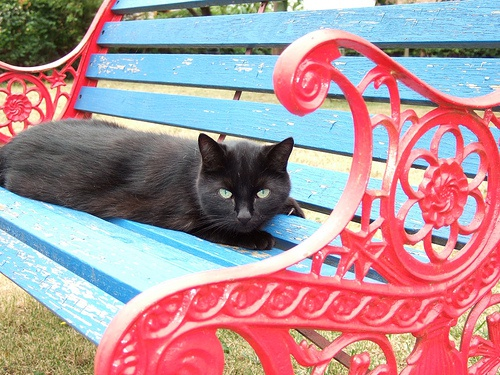Describe the objects in this image and their specific colors. I can see bench in lightblue, ivory, salmon, gray, and darkgreen tones and cat in darkgreen, black, gray, and darkgray tones in this image. 